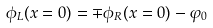<formula> <loc_0><loc_0><loc_500><loc_500>\phi _ { L } ( x = 0 ) = \mp \phi _ { R } ( x = 0 ) - \varphi _ { 0 }</formula> 